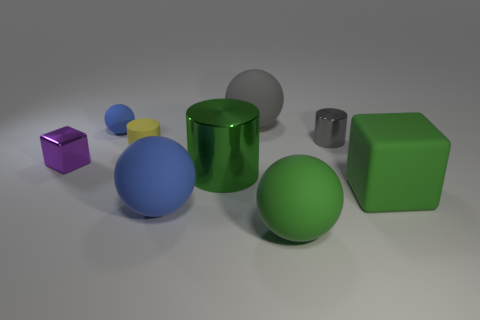Subtract 1 spheres. How many spheres are left? 3 Subtract all cyan balls. Subtract all blue cylinders. How many balls are left? 4 Add 1 shiny cylinders. How many objects exist? 10 Subtract all cylinders. How many objects are left? 6 Subtract 1 green blocks. How many objects are left? 8 Subtract all big metallic cylinders. Subtract all cubes. How many objects are left? 6 Add 6 tiny yellow things. How many tiny yellow things are left? 7 Add 7 small yellow cylinders. How many small yellow cylinders exist? 8 